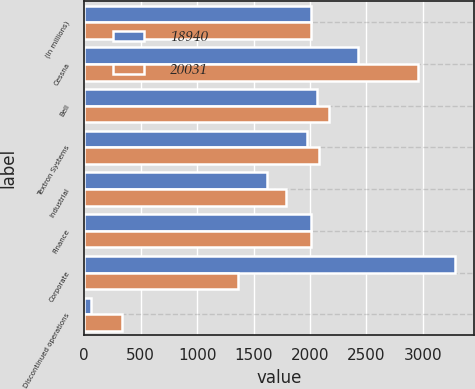Convert chart to OTSL. <chart><loc_0><loc_0><loc_500><loc_500><stacked_bar_chart><ecel><fcel>(In millions)<fcel>Cessna<fcel>Bell<fcel>Textron Systems<fcel>Industrial<fcel>Finance<fcel>Corporate<fcel>Discontinued operations<nl><fcel>18940<fcel>2009<fcel>2427<fcel>2059<fcel>1973<fcel>1623<fcel>2008.5<fcel>3288<fcel>58<nl><fcel>20031<fcel>2008<fcel>2955<fcel>2167<fcel>2077<fcel>1788<fcel>2008.5<fcel>1366<fcel>334<nl></chart> 